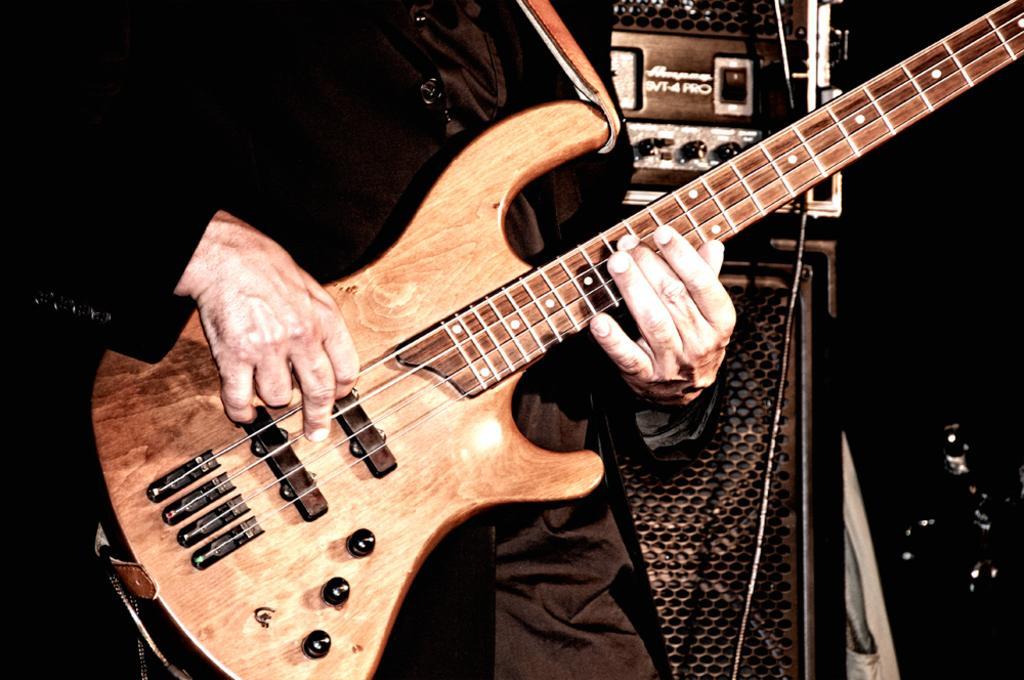Could you give a brief overview of what you see in this image? In this image, there is a person holding and playing a guitar. This person is wearing clothes. There are speakers behind this person. 